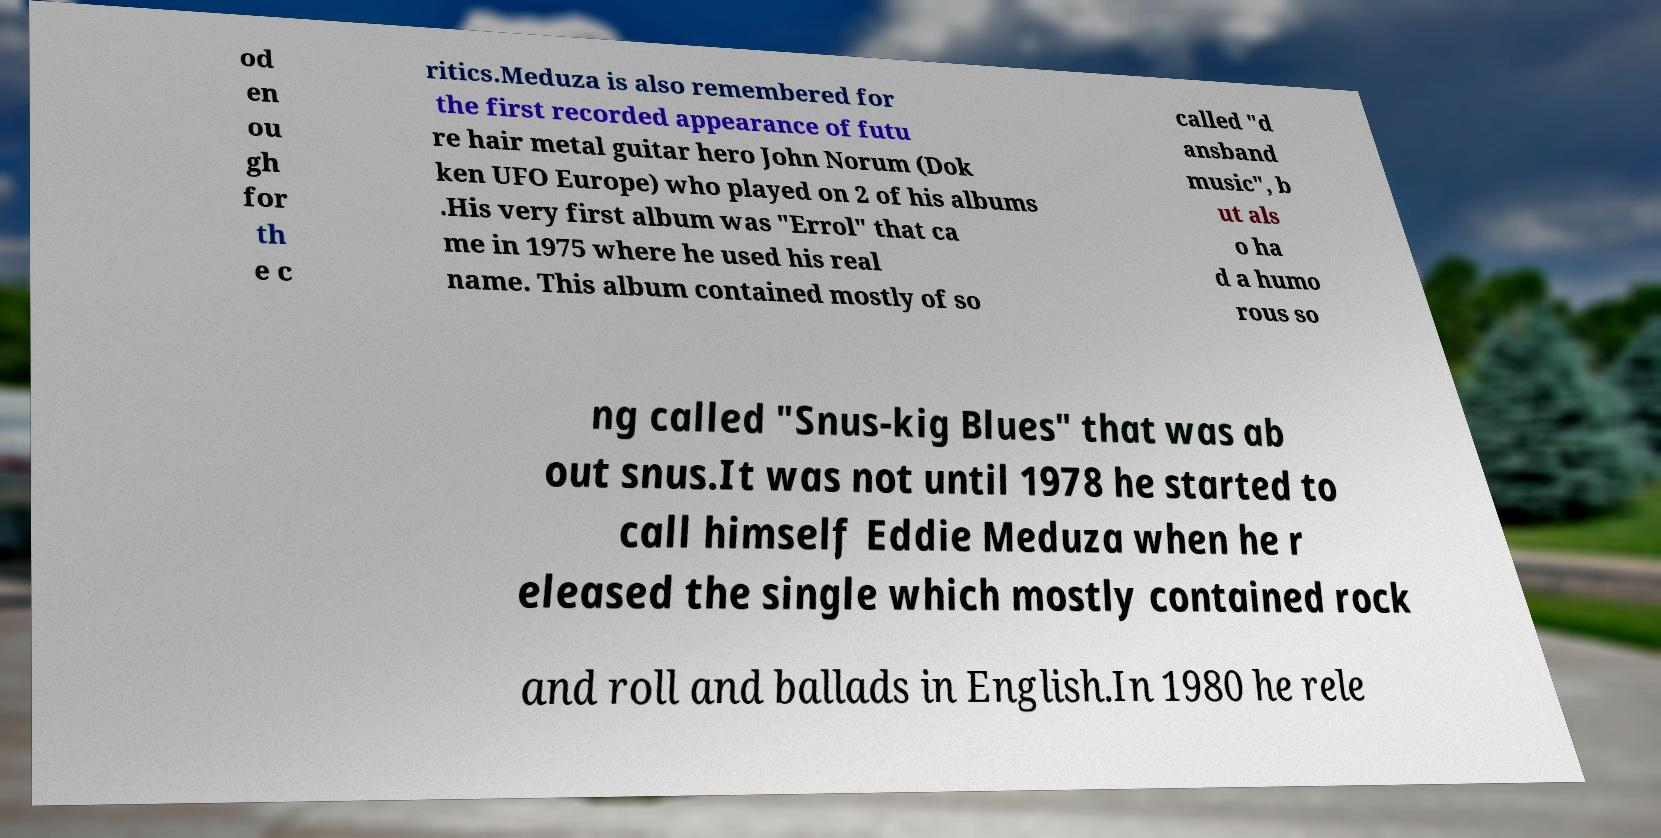Could you extract and type out the text from this image? od en ou gh for th e c ritics.Meduza is also remembered for the first recorded appearance of futu re hair metal guitar hero John Norum (Dok ken UFO Europe) who played on 2 of his albums .His very first album was "Errol" that ca me in 1975 where he used his real name. This album contained mostly of so called "d ansband music", b ut als o ha d a humo rous so ng called "Snus-kig Blues" that was ab out snus.It was not until 1978 he started to call himself Eddie Meduza when he r eleased the single which mostly contained rock and roll and ballads in English.In 1980 he rele 